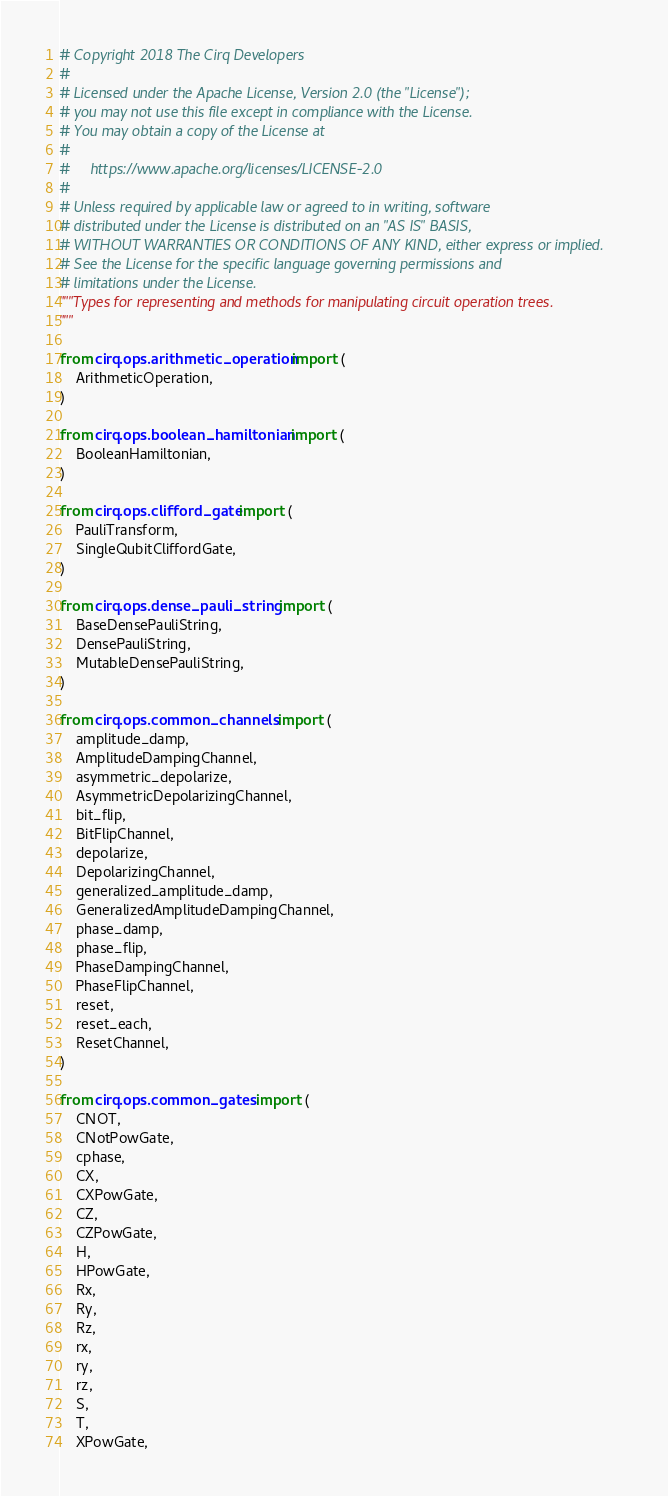Convert code to text. <code><loc_0><loc_0><loc_500><loc_500><_Python_># Copyright 2018 The Cirq Developers
#
# Licensed under the Apache License, Version 2.0 (the "License");
# you may not use this file except in compliance with the License.
# You may obtain a copy of the License at
#
#     https://www.apache.org/licenses/LICENSE-2.0
#
# Unless required by applicable law or agreed to in writing, software
# distributed under the License is distributed on an "AS IS" BASIS,
# WITHOUT WARRANTIES OR CONDITIONS OF ANY KIND, either express or implied.
# See the License for the specific language governing permissions and
# limitations under the License.
"""Types for representing and methods for manipulating circuit operation trees.
"""

from cirq.ops.arithmetic_operation import (
    ArithmeticOperation,
)

from cirq.ops.boolean_hamiltonian import (
    BooleanHamiltonian,
)

from cirq.ops.clifford_gate import (
    PauliTransform,
    SingleQubitCliffordGate,
)

from cirq.ops.dense_pauli_string import (
    BaseDensePauliString,
    DensePauliString,
    MutableDensePauliString,
)

from cirq.ops.common_channels import (
    amplitude_damp,
    AmplitudeDampingChannel,
    asymmetric_depolarize,
    AsymmetricDepolarizingChannel,
    bit_flip,
    BitFlipChannel,
    depolarize,
    DepolarizingChannel,
    generalized_amplitude_damp,
    GeneralizedAmplitudeDampingChannel,
    phase_damp,
    phase_flip,
    PhaseDampingChannel,
    PhaseFlipChannel,
    reset,
    reset_each,
    ResetChannel,
)

from cirq.ops.common_gates import (
    CNOT,
    CNotPowGate,
    cphase,
    CX,
    CXPowGate,
    CZ,
    CZPowGate,
    H,
    HPowGate,
    Rx,
    Ry,
    Rz,
    rx,
    ry,
    rz,
    S,
    T,
    XPowGate,</code> 